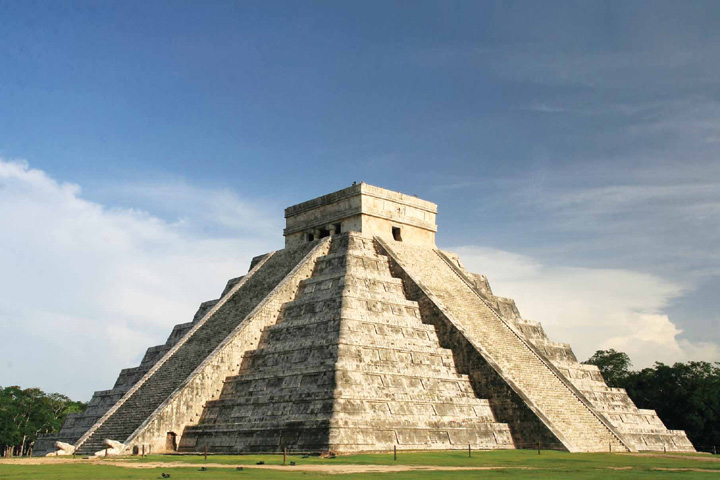How does Chichen Itza exemplify the astronomical knowledge of the Mayans? Chichen Itza is a testament to the advanced astronomical knowledge possessed by the Mayans. The pyramid's design aligns with the solar calendar, particularly during the equinoxes. On these days, the setting sun casts shadows on the pyramid's steps, creating the illusion of a descending serpent along the side of the northern staircase, symbolizing Kukulcan. This precision underscores the Mayans' ability to integrate celestial movements with architectural designs, serving both religious and calendrical purposes. 